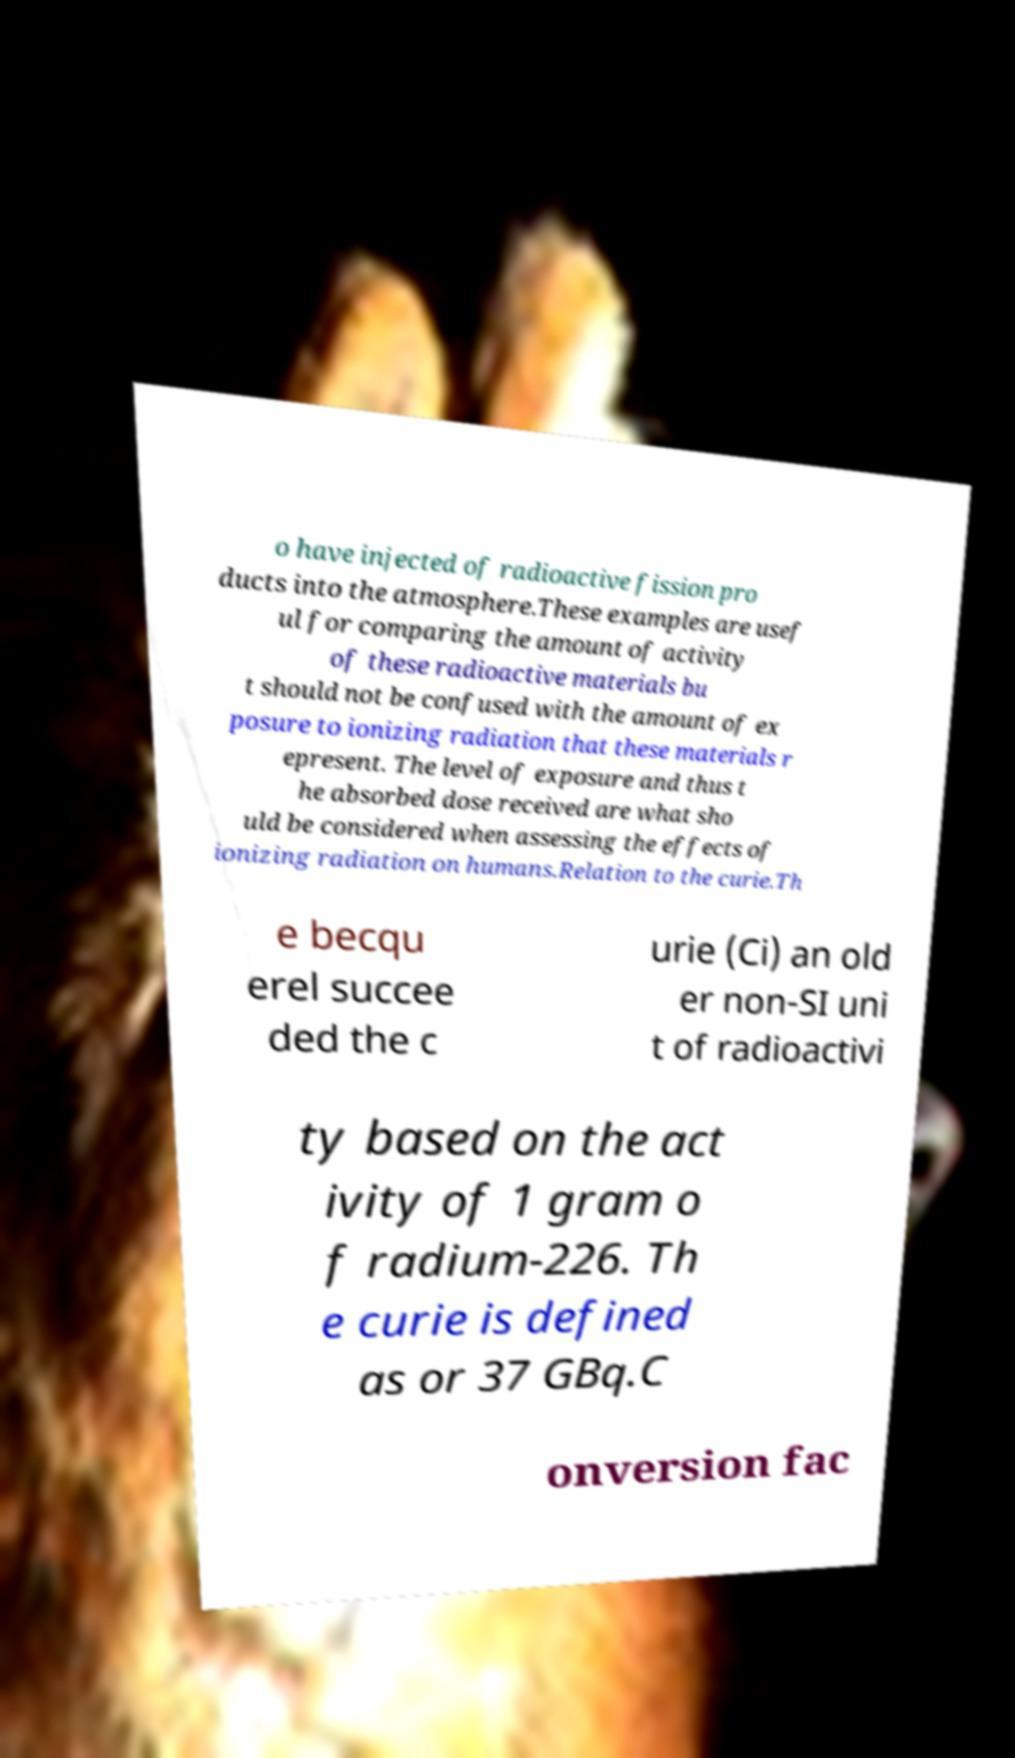Could you assist in decoding the text presented in this image and type it out clearly? o have injected of radioactive fission pro ducts into the atmosphere.These examples are usef ul for comparing the amount of activity of these radioactive materials bu t should not be confused with the amount of ex posure to ionizing radiation that these materials r epresent. The level of exposure and thus t he absorbed dose received are what sho uld be considered when assessing the effects of ionizing radiation on humans.Relation to the curie.Th e becqu erel succee ded the c urie (Ci) an old er non-SI uni t of radioactivi ty based on the act ivity of 1 gram o f radium-226. Th e curie is defined as or 37 GBq.C onversion fac 